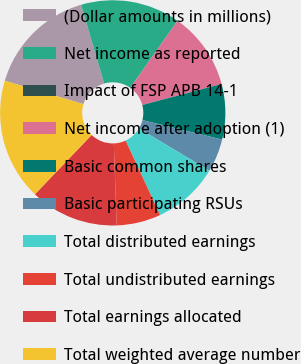Convert chart. <chart><loc_0><loc_0><loc_500><loc_500><pie_chart><fcel>(Dollar amounts in millions)<fcel>Net income as reported<fcel>Impact of FSP APB 14-1<fcel>Net income after adoption (1)<fcel>Basic common shares<fcel>Basic participating RSUs<fcel>Total distributed earnings<fcel>Total undistributed earnings<fcel>Total earnings allocated<fcel>Total weighted average number<nl><fcel>15.87%<fcel>14.29%<fcel>0.0%<fcel>11.11%<fcel>7.94%<fcel>4.76%<fcel>9.52%<fcel>6.35%<fcel>12.7%<fcel>17.46%<nl></chart> 